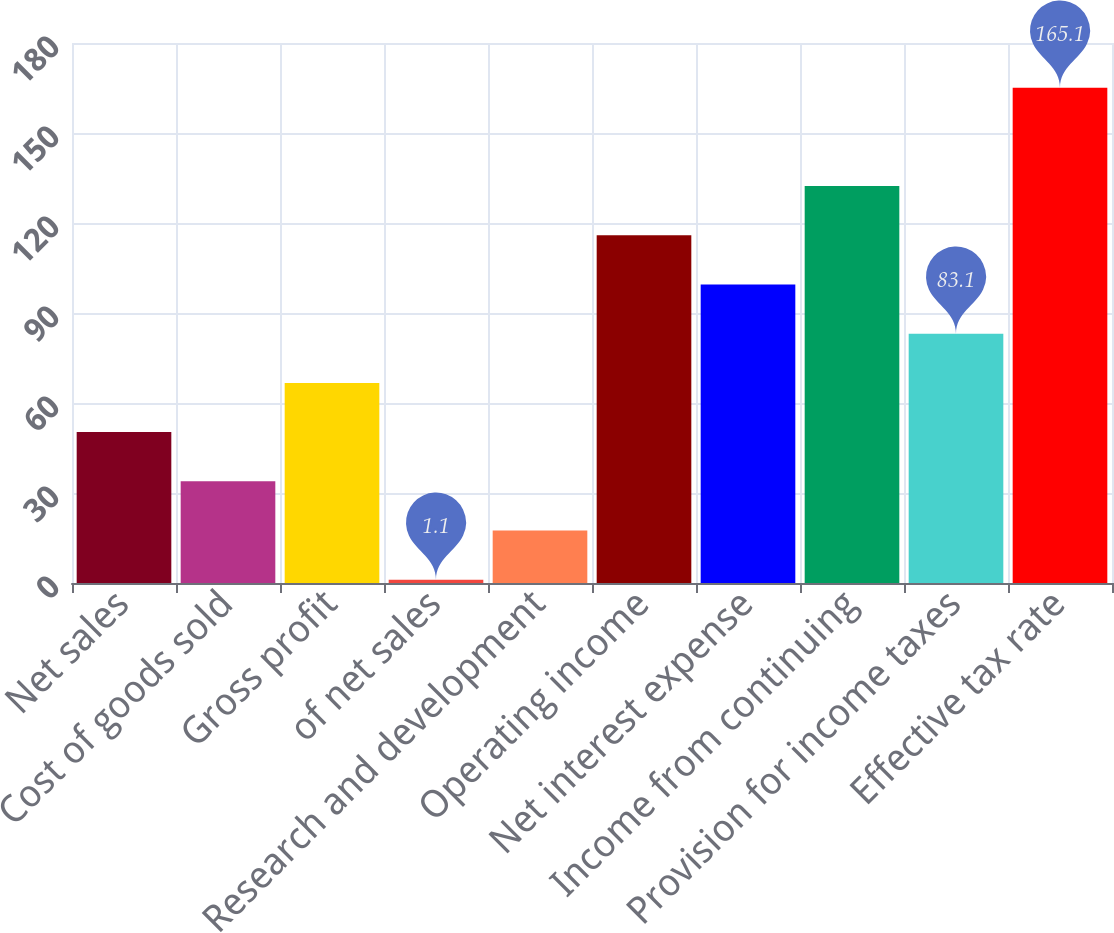Convert chart to OTSL. <chart><loc_0><loc_0><loc_500><loc_500><bar_chart><fcel>Net sales<fcel>Cost of goods sold<fcel>Gross profit<fcel>of net sales<fcel>Research and development<fcel>Operating income<fcel>Net interest expense<fcel>Income from continuing<fcel>Provision for income taxes<fcel>Effective tax rate<nl><fcel>50.3<fcel>33.9<fcel>66.7<fcel>1.1<fcel>17.5<fcel>115.9<fcel>99.5<fcel>132.3<fcel>83.1<fcel>165.1<nl></chart> 